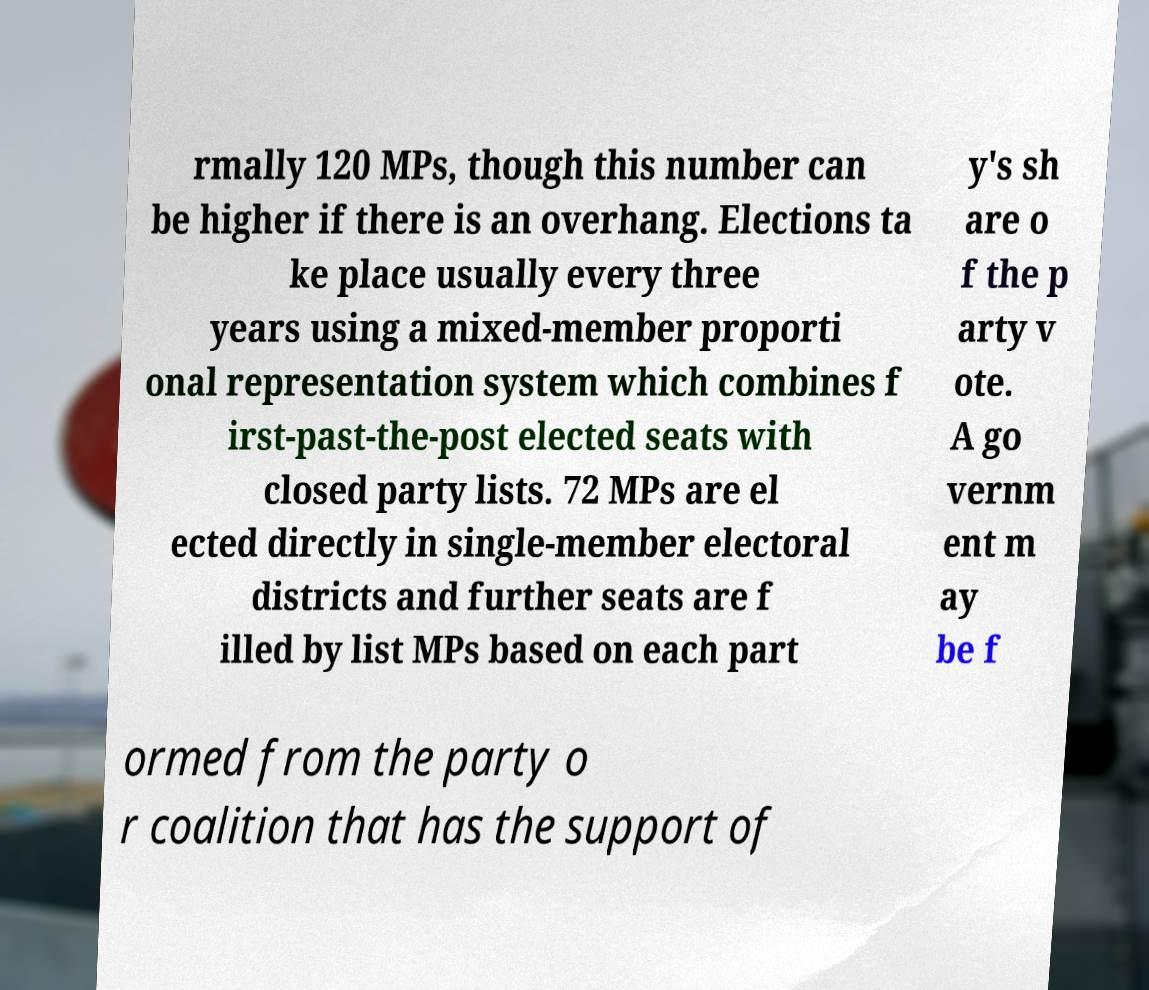Can you read and provide the text displayed in the image?This photo seems to have some interesting text. Can you extract and type it out for me? rmally 120 MPs, though this number can be higher if there is an overhang. Elections ta ke place usually every three years using a mixed-member proporti onal representation system which combines f irst-past-the-post elected seats with closed party lists. 72 MPs are el ected directly in single-member electoral districts and further seats are f illed by list MPs based on each part y's sh are o f the p arty v ote. A go vernm ent m ay be f ormed from the party o r coalition that has the support of 